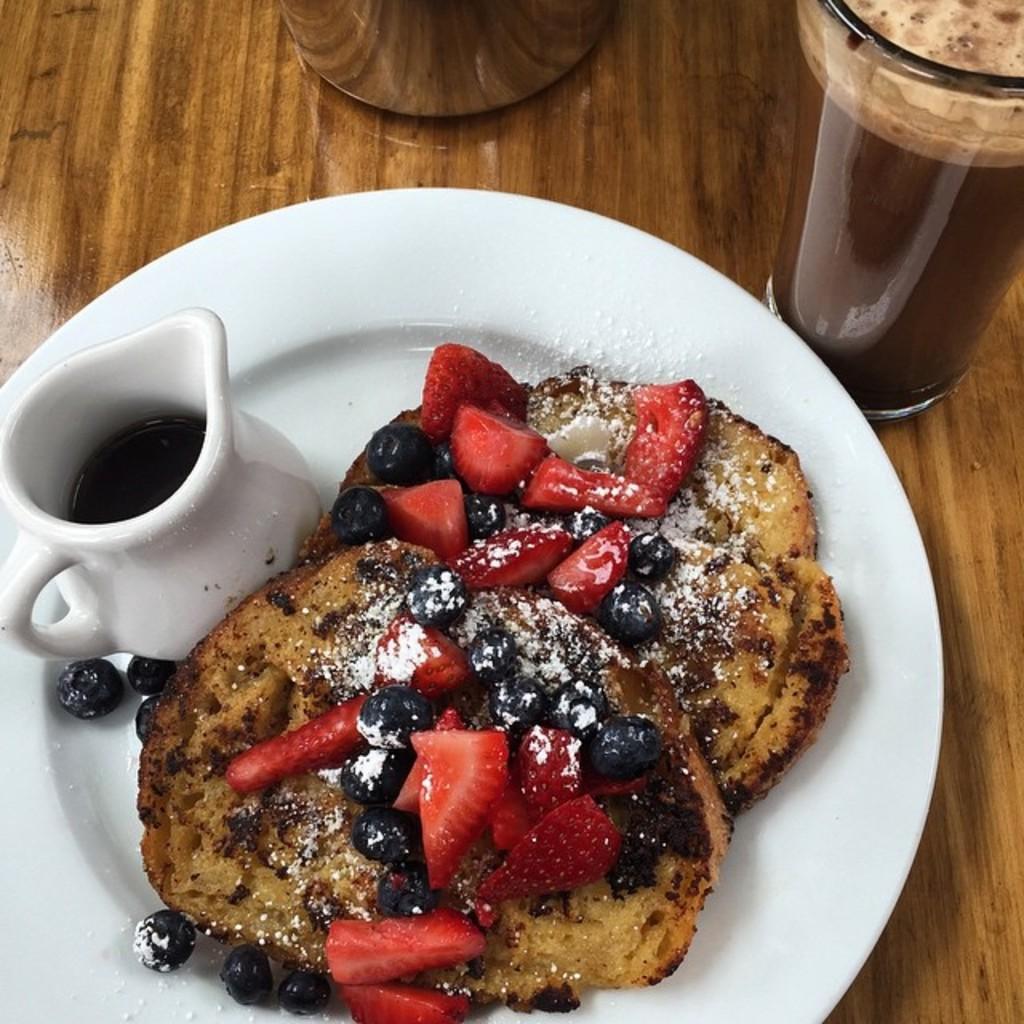Describe this image in one or two sentences. There is a wooden surface. On that there is a glass with a drink. Also there is a plate. On the plate there is a jug with some item. Also there is a food item with pieces of strawberries, some other fruits and some other things. 